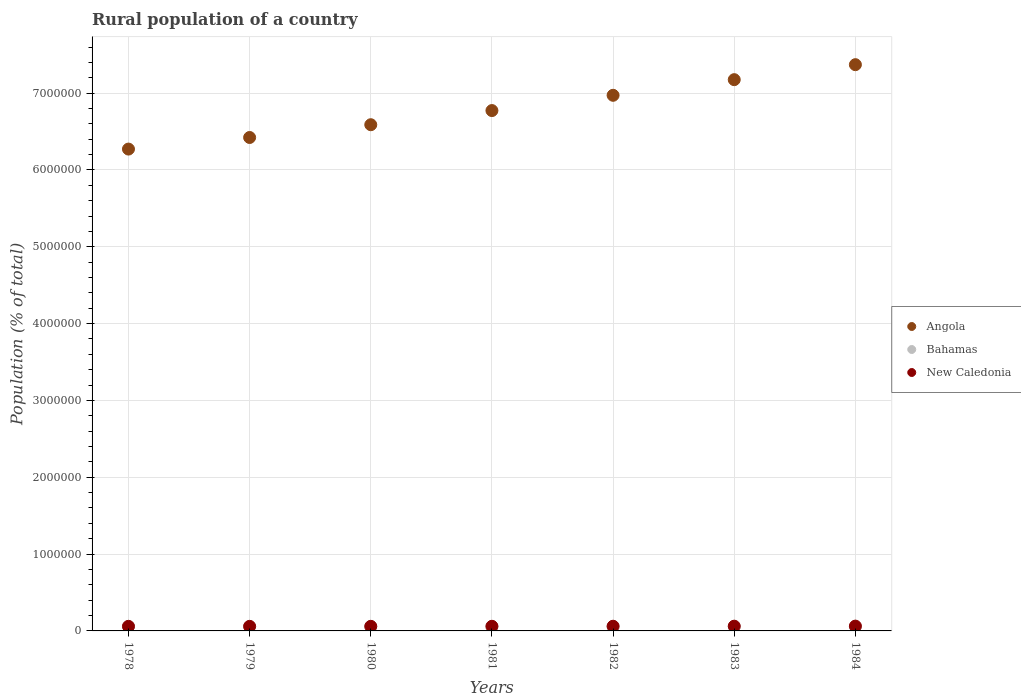How many different coloured dotlines are there?
Make the answer very short. 3. Is the number of dotlines equal to the number of legend labels?
Make the answer very short. Yes. What is the rural population in New Caledonia in 1982?
Provide a short and direct response. 6.09e+04. Across all years, what is the maximum rural population in Bahamas?
Ensure brevity in your answer.  5.67e+04. Across all years, what is the minimum rural population in New Caledonia?
Offer a very short reply. 5.95e+04. In which year was the rural population in Bahamas maximum?
Give a very brief answer. 1979. In which year was the rural population in New Caledonia minimum?
Make the answer very short. 1979. What is the total rural population in Angola in the graph?
Ensure brevity in your answer.  4.76e+07. What is the difference between the rural population in Angola in 1978 and that in 1984?
Offer a very short reply. -1.10e+06. What is the difference between the rural population in New Caledonia in 1983 and the rural population in Bahamas in 1980?
Provide a short and direct response. 5000. What is the average rural population in Bahamas per year?
Ensure brevity in your answer.  5.62e+04. In the year 1984, what is the difference between the rural population in Angola and rural population in Bahamas?
Offer a very short reply. 7.32e+06. What is the ratio of the rural population in Angola in 1979 to that in 1984?
Provide a short and direct response. 0.87. Is the difference between the rural population in Angola in 1981 and 1983 greater than the difference between the rural population in Bahamas in 1981 and 1983?
Offer a terse response. No. What is the difference between the highest and the second highest rural population in Bahamas?
Keep it short and to the point. 26. What is the difference between the highest and the lowest rural population in New Caledonia?
Give a very brief answer. 3156. In how many years, is the rural population in Angola greater than the average rural population in Angola taken over all years?
Make the answer very short. 3. Is the sum of the rural population in Angola in 1980 and 1983 greater than the maximum rural population in New Caledonia across all years?
Give a very brief answer. Yes. Does the rural population in New Caledonia monotonically increase over the years?
Offer a terse response. No. How many dotlines are there?
Give a very brief answer. 3. What is the difference between two consecutive major ticks on the Y-axis?
Offer a very short reply. 1.00e+06. Are the values on the major ticks of Y-axis written in scientific E-notation?
Offer a terse response. No. Does the graph contain any zero values?
Give a very brief answer. No. What is the title of the graph?
Make the answer very short. Rural population of a country. What is the label or title of the X-axis?
Keep it short and to the point. Years. What is the label or title of the Y-axis?
Offer a terse response. Population (% of total). What is the Population (% of total) of Angola in 1978?
Make the answer very short. 6.27e+06. What is the Population (% of total) in Bahamas in 1978?
Provide a succinct answer. 5.67e+04. What is the Population (% of total) in New Caledonia in 1978?
Provide a short and direct response. 5.96e+04. What is the Population (% of total) of Angola in 1979?
Your answer should be very brief. 6.42e+06. What is the Population (% of total) of Bahamas in 1979?
Give a very brief answer. 5.67e+04. What is the Population (% of total) in New Caledonia in 1979?
Your answer should be compact. 5.95e+04. What is the Population (% of total) in Angola in 1980?
Keep it short and to the point. 6.59e+06. What is the Population (% of total) in Bahamas in 1980?
Ensure brevity in your answer.  5.67e+04. What is the Population (% of total) of New Caledonia in 1980?
Make the answer very short. 5.96e+04. What is the Population (% of total) in Angola in 1981?
Your answer should be compact. 6.77e+06. What is the Population (% of total) in Bahamas in 1981?
Give a very brief answer. 5.63e+04. What is the Population (% of total) of New Caledonia in 1981?
Offer a terse response. 6.02e+04. What is the Population (% of total) in Angola in 1982?
Give a very brief answer. 6.97e+06. What is the Population (% of total) of Bahamas in 1982?
Provide a short and direct response. 5.60e+04. What is the Population (% of total) in New Caledonia in 1982?
Offer a terse response. 6.09e+04. What is the Population (% of total) in Angola in 1983?
Ensure brevity in your answer.  7.18e+06. What is the Population (% of total) in Bahamas in 1983?
Your answer should be compact. 5.57e+04. What is the Population (% of total) of New Caledonia in 1983?
Provide a succinct answer. 6.17e+04. What is the Population (% of total) of Angola in 1984?
Your response must be concise. 7.37e+06. What is the Population (% of total) in Bahamas in 1984?
Offer a terse response. 5.52e+04. What is the Population (% of total) of New Caledonia in 1984?
Ensure brevity in your answer.  6.27e+04. Across all years, what is the maximum Population (% of total) of Angola?
Offer a very short reply. 7.37e+06. Across all years, what is the maximum Population (% of total) in Bahamas?
Keep it short and to the point. 5.67e+04. Across all years, what is the maximum Population (% of total) of New Caledonia?
Offer a terse response. 6.27e+04. Across all years, what is the minimum Population (% of total) of Angola?
Offer a terse response. 6.27e+06. Across all years, what is the minimum Population (% of total) in Bahamas?
Offer a terse response. 5.52e+04. Across all years, what is the minimum Population (% of total) in New Caledonia?
Provide a short and direct response. 5.95e+04. What is the total Population (% of total) of Angola in the graph?
Ensure brevity in your answer.  4.76e+07. What is the total Population (% of total) of Bahamas in the graph?
Offer a terse response. 3.93e+05. What is the total Population (% of total) in New Caledonia in the graph?
Offer a very short reply. 4.24e+05. What is the difference between the Population (% of total) of Angola in 1978 and that in 1979?
Make the answer very short. -1.51e+05. What is the difference between the Population (% of total) of Bahamas in 1978 and that in 1979?
Keep it short and to the point. -26. What is the difference between the Population (% of total) of New Caledonia in 1978 and that in 1979?
Your answer should be very brief. 104. What is the difference between the Population (% of total) in Angola in 1978 and that in 1980?
Provide a succinct answer. -3.17e+05. What is the difference between the Population (% of total) of Angola in 1978 and that in 1981?
Your response must be concise. -5.01e+05. What is the difference between the Population (% of total) of Bahamas in 1978 and that in 1981?
Make the answer very short. 324. What is the difference between the Population (% of total) in New Caledonia in 1978 and that in 1981?
Ensure brevity in your answer.  -576. What is the difference between the Population (% of total) of Angola in 1978 and that in 1982?
Make the answer very short. -7.00e+05. What is the difference between the Population (% of total) of Bahamas in 1978 and that in 1982?
Provide a short and direct response. 653. What is the difference between the Population (% of total) in New Caledonia in 1978 and that in 1982?
Your answer should be compact. -1302. What is the difference between the Population (% of total) in Angola in 1978 and that in 1983?
Offer a terse response. -9.04e+05. What is the difference between the Population (% of total) of Bahamas in 1978 and that in 1983?
Ensure brevity in your answer.  1013. What is the difference between the Population (% of total) of New Caledonia in 1978 and that in 1983?
Provide a short and direct response. -2058. What is the difference between the Population (% of total) in Angola in 1978 and that in 1984?
Provide a short and direct response. -1.10e+06. What is the difference between the Population (% of total) of Bahamas in 1978 and that in 1984?
Your response must be concise. 1433. What is the difference between the Population (% of total) of New Caledonia in 1978 and that in 1984?
Your response must be concise. -3052. What is the difference between the Population (% of total) in Angola in 1979 and that in 1980?
Give a very brief answer. -1.66e+05. What is the difference between the Population (% of total) of New Caledonia in 1979 and that in 1980?
Make the answer very short. -124. What is the difference between the Population (% of total) of Angola in 1979 and that in 1981?
Provide a short and direct response. -3.50e+05. What is the difference between the Population (% of total) in Bahamas in 1979 and that in 1981?
Offer a very short reply. 350. What is the difference between the Population (% of total) of New Caledonia in 1979 and that in 1981?
Offer a terse response. -680. What is the difference between the Population (% of total) in Angola in 1979 and that in 1982?
Ensure brevity in your answer.  -5.49e+05. What is the difference between the Population (% of total) in Bahamas in 1979 and that in 1982?
Offer a very short reply. 679. What is the difference between the Population (% of total) in New Caledonia in 1979 and that in 1982?
Give a very brief answer. -1406. What is the difference between the Population (% of total) in Angola in 1979 and that in 1983?
Your answer should be compact. -7.53e+05. What is the difference between the Population (% of total) in Bahamas in 1979 and that in 1983?
Make the answer very short. 1039. What is the difference between the Population (% of total) of New Caledonia in 1979 and that in 1983?
Give a very brief answer. -2162. What is the difference between the Population (% of total) in Angola in 1979 and that in 1984?
Keep it short and to the point. -9.48e+05. What is the difference between the Population (% of total) of Bahamas in 1979 and that in 1984?
Your answer should be compact. 1459. What is the difference between the Population (% of total) in New Caledonia in 1979 and that in 1984?
Give a very brief answer. -3156. What is the difference between the Population (% of total) in Angola in 1980 and that in 1981?
Provide a short and direct response. -1.84e+05. What is the difference between the Population (% of total) in Bahamas in 1980 and that in 1981?
Give a very brief answer. 320. What is the difference between the Population (% of total) of New Caledonia in 1980 and that in 1981?
Ensure brevity in your answer.  -556. What is the difference between the Population (% of total) of Angola in 1980 and that in 1982?
Your answer should be compact. -3.83e+05. What is the difference between the Population (% of total) in Bahamas in 1980 and that in 1982?
Ensure brevity in your answer.  649. What is the difference between the Population (% of total) of New Caledonia in 1980 and that in 1982?
Your response must be concise. -1282. What is the difference between the Population (% of total) of Angola in 1980 and that in 1983?
Provide a succinct answer. -5.87e+05. What is the difference between the Population (% of total) in Bahamas in 1980 and that in 1983?
Make the answer very short. 1009. What is the difference between the Population (% of total) in New Caledonia in 1980 and that in 1983?
Offer a terse response. -2038. What is the difference between the Population (% of total) in Angola in 1980 and that in 1984?
Offer a terse response. -7.82e+05. What is the difference between the Population (% of total) of Bahamas in 1980 and that in 1984?
Your response must be concise. 1429. What is the difference between the Population (% of total) in New Caledonia in 1980 and that in 1984?
Offer a terse response. -3032. What is the difference between the Population (% of total) of Angola in 1981 and that in 1982?
Offer a terse response. -1.99e+05. What is the difference between the Population (% of total) of Bahamas in 1981 and that in 1982?
Your answer should be very brief. 329. What is the difference between the Population (% of total) in New Caledonia in 1981 and that in 1982?
Provide a short and direct response. -726. What is the difference between the Population (% of total) of Angola in 1981 and that in 1983?
Provide a short and direct response. -4.02e+05. What is the difference between the Population (% of total) in Bahamas in 1981 and that in 1983?
Provide a short and direct response. 689. What is the difference between the Population (% of total) of New Caledonia in 1981 and that in 1983?
Make the answer very short. -1482. What is the difference between the Population (% of total) in Angola in 1981 and that in 1984?
Your response must be concise. -5.97e+05. What is the difference between the Population (% of total) of Bahamas in 1981 and that in 1984?
Provide a succinct answer. 1109. What is the difference between the Population (% of total) in New Caledonia in 1981 and that in 1984?
Your answer should be very brief. -2476. What is the difference between the Population (% of total) of Angola in 1982 and that in 1983?
Provide a short and direct response. -2.04e+05. What is the difference between the Population (% of total) in Bahamas in 1982 and that in 1983?
Your answer should be very brief. 360. What is the difference between the Population (% of total) in New Caledonia in 1982 and that in 1983?
Offer a terse response. -756. What is the difference between the Population (% of total) of Angola in 1982 and that in 1984?
Your answer should be very brief. -3.99e+05. What is the difference between the Population (% of total) of Bahamas in 1982 and that in 1984?
Give a very brief answer. 780. What is the difference between the Population (% of total) of New Caledonia in 1982 and that in 1984?
Give a very brief answer. -1750. What is the difference between the Population (% of total) in Angola in 1983 and that in 1984?
Your answer should be very brief. -1.95e+05. What is the difference between the Population (% of total) of Bahamas in 1983 and that in 1984?
Provide a succinct answer. 420. What is the difference between the Population (% of total) in New Caledonia in 1983 and that in 1984?
Ensure brevity in your answer.  -994. What is the difference between the Population (% of total) in Angola in 1978 and the Population (% of total) in Bahamas in 1979?
Offer a terse response. 6.22e+06. What is the difference between the Population (% of total) in Angola in 1978 and the Population (% of total) in New Caledonia in 1979?
Offer a very short reply. 6.21e+06. What is the difference between the Population (% of total) in Bahamas in 1978 and the Population (% of total) in New Caledonia in 1979?
Your response must be concise. -2834. What is the difference between the Population (% of total) of Angola in 1978 and the Population (% of total) of Bahamas in 1980?
Ensure brevity in your answer.  6.22e+06. What is the difference between the Population (% of total) in Angola in 1978 and the Population (% of total) in New Caledonia in 1980?
Your answer should be compact. 6.21e+06. What is the difference between the Population (% of total) of Bahamas in 1978 and the Population (% of total) of New Caledonia in 1980?
Give a very brief answer. -2958. What is the difference between the Population (% of total) of Angola in 1978 and the Population (% of total) of Bahamas in 1981?
Keep it short and to the point. 6.22e+06. What is the difference between the Population (% of total) of Angola in 1978 and the Population (% of total) of New Caledonia in 1981?
Give a very brief answer. 6.21e+06. What is the difference between the Population (% of total) of Bahamas in 1978 and the Population (% of total) of New Caledonia in 1981?
Your answer should be very brief. -3514. What is the difference between the Population (% of total) of Angola in 1978 and the Population (% of total) of Bahamas in 1982?
Your response must be concise. 6.22e+06. What is the difference between the Population (% of total) of Angola in 1978 and the Population (% of total) of New Caledonia in 1982?
Your answer should be compact. 6.21e+06. What is the difference between the Population (% of total) in Bahamas in 1978 and the Population (% of total) in New Caledonia in 1982?
Ensure brevity in your answer.  -4240. What is the difference between the Population (% of total) of Angola in 1978 and the Population (% of total) of Bahamas in 1983?
Your answer should be compact. 6.22e+06. What is the difference between the Population (% of total) in Angola in 1978 and the Population (% of total) in New Caledonia in 1983?
Keep it short and to the point. 6.21e+06. What is the difference between the Population (% of total) of Bahamas in 1978 and the Population (% of total) of New Caledonia in 1983?
Ensure brevity in your answer.  -4996. What is the difference between the Population (% of total) in Angola in 1978 and the Population (% of total) in Bahamas in 1984?
Provide a succinct answer. 6.22e+06. What is the difference between the Population (% of total) in Angola in 1978 and the Population (% of total) in New Caledonia in 1984?
Your answer should be very brief. 6.21e+06. What is the difference between the Population (% of total) of Bahamas in 1978 and the Population (% of total) of New Caledonia in 1984?
Your response must be concise. -5990. What is the difference between the Population (% of total) of Angola in 1979 and the Population (% of total) of Bahamas in 1980?
Ensure brevity in your answer.  6.37e+06. What is the difference between the Population (% of total) in Angola in 1979 and the Population (% of total) in New Caledonia in 1980?
Provide a succinct answer. 6.36e+06. What is the difference between the Population (% of total) of Bahamas in 1979 and the Population (% of total) of New Caledonia in 1980?
Give a very brief answer. -2932. What is the difference between the Population (% of total) of Angola in 1979 and the Population (% of total) of Bahamas in 1981?
Offer a very short reply. 6.37e+06. What is the difference between the Population (% of total) in Angola in 1979 and the Population (% of total) in New Caledonia in 1981?
Provide a succinct answer. 6.36e+06. What is the difference between the Population (% of total) in Bahamas in 1979 and the Population (% of total) in New Caledonia in 1981?
Keep it short and to the point. -3488. What is the difference between the Population (% of total) of Angola in 1979 and the Population (% of total) of Bahamas in 1982?
Provide a succinct answer. 6.37e+06. What is the difference between the Population (% of total) of Angola in 1979 and the Population (% of total) of New Caledonia in 1982?
Your answer should be very brief. 6.36e+06. What is the difference between the Population (% of total) of Bahamas in 1979 and the Population (% of total) of New Caledonia in 1982?
Give a very brief answer. -4214. What is the difference between the Population (% of total) in Angola in 1979 and the Population (% of total) in Bahamas in 1983?
Give a very brief answer. 6.37e+06. What is the difference between the Population (% of total) in Angola in 1979 and the Population (% of total) in New Caledonia in 1983?
Your answer should be very brief. 6.36e+06. What is the difference between the Population (% of total) in Bahamas in 1979 and the Population (% of total) in New Caledonia in 1983?
Your answer should be very brief. -4970. What is the difference between the Population (% of total) in Angola in 1979 and the Population (% of total) in Bahamas in 1984?
Offer a very short reply. 6.37e+06. What is the difference between the Population (% of total) in Angola in 1979 and the Population (% of total) in New Caledonia in 1984?
Keep it short and to the point. 6.36e+06. What is the difference between the Population (% of total) of Bahamas in 1979 and the Population (% of total) of New Caledonia in 1984?
Offer a very short reply. -5964. What is the difference between the Population (% of total) of Angola in 1980 and the Population (% of total) of Bahamas in 1981?
Your answer should be compact. 6.53e+06. What is the difference between the Population (% of total) in Angola in 1980 and the Population (% of total) in New Caledonia in 1981?
Your answer should be compact. 6.53e+06. What is the difference between the Population (% of total) of Bahamas in 1980 and the Population (% of total) of New Caledonia in 1981?
Provide a short and direct response. -3518. What is the difference between the Population (% of total) in Angola in 1980 and the Population (% of total) in Bahamas in 1982?
Your answer should be compact. 6.53e+06. What is the difference between the Population (% of total) in Angola in 1980 and the Population (% of total) in New Caledonia in 1982?
Provide a short and direct response. 6.53e+06. What is the difference between the Population (% of total) of Bahamas in 1980 and the Population (% of total) of New Caledonia in 1982?
Your answer should be compact. -4244. What is the difference between the Population (% of total) of Angola in 1980 and the Population (% of total) of Bahamas in 1983?
Your answer should be compact. 6.53e+06. What is the difference between the Population (% of total) of Angola in 1980 and the Population (% of total) of New Caledonia in 1983?
Offer a terse response. 6.53e+06. What is the difference between the Population (% of total) in Bahamas in 1980 and the Population (% of total) in New Caledonia in 1983?
Keep it short and to the point. -5000. What is the difference between the Population (% of total) of Angola in 1980 and the Population (% of total) of Bahamas in 1984?
Give a very brief answer. 6.53e+06. What is the difference between the Population (% of total) in Angola in 1980 and the Population (% of total) in New Caledonia in 1984?
Ensure brevity in your answer.  6.53e+06. What is the difference between the Population (% of total) in Bahamas in 1980 and the Population (% of total) in New Caledonia in 1984?
Keep it short and to the point. -5994. What is the difference between the Population (% of total) of Angola in 1981 and the Population (% of total) of Bahamas in 1982?
Provide a short and direct response. 6.72e+06. What is the difference between the Population (% of total) of Angola in 1981 and the Population (% of total) of New Caledonia in 1982?
Your answer should be very brief. 6.71e+06. What is the difference between the Population (% of total) of Bahamas in 1981 and the Population (% of total) of New Caledonia in 1982?
Your answer should be compact. -4564. What is the difference between the Population (% of total) of Angola in 1981 and the Population (% of total) of Bahamas in 1983?
Provide a short and direct response. 6.72e+06. What is the difference between the Population (% of total) in Angola in 1981 and the Population (% of total) in New Caledonia in 1983?
Provide a short and direct response. 6.71e+06. What is the difference between the Population (% of total) in Bahamas in 1981 and the Population (% of total) in New Caledonia in 1983?
Your answer should be very brief. -5320. What is the difference between the Population (% of total) of Angola in 1981 and the Population (% of total) of Bahamas in 1984?
Give a very brief answer. 6.72e+06. What is the difference between the Population (% of total) in Angola in 1981 and the Population (% of total) in New Caledonia in 1984?
Offer a very short reply. 6.71e+06. What is the difference between the Population (% of total) of Bahamas in 1981 and the Population (% of total) of New Caledonia in 1984?
Make the answer very short. -6314. What is the difference between the Population (% of total) in Angola in 1982 and the Population (% of total) in Bahamas in 1983?
Make the answer very short. 6.92e+06. What is the difference between the Population (% of total) in Angola in 1982 and the Population (% of total) in New Caledonia in 1983?
Ensure brevity in your answer.  6.91e+06. What is the difference between the Population (% of total) in Bahamas in 1982 and the Population (% of total) in New Caledonia in 1983?
Offer a very short reply. -5649. What is the difference between the Population (% of total) of Angola in 1982 and the Population (% of total) of Bahamas in 1984?
Ensure brevity in your answer.  6.92e+06. What is the difference between the Population (% of total) of Angola in 1982 and the Population (% of total) of New Caledonia in 1984?
Your answer should be compact. 6.91e+06. What is the difference between the Population (% of total) of Bahamas in 1982 and the Population (% of total) of New Caledonia in 1984?
Make the answer very short. -6643. What is the difference between the Population (% of total) of Angola in 1983 and the Population (% of total) of Bahamas in 1984?
Provide a succinct answer. 7.12e+06. What is the difference between the Population (% of total) of Angola in 1983 and the Population (% of total) of New Caledonia in 1984?
Offer a terse response. 7.11e+06. What is the difference between the Population (% of total) of Bahamas in 1983 and the Population (% of total) of New Caledonia in 1984?
Provide a short and direct response. -7003. What is the average Population (% of total) of Angola per year?
Offer a very short reply. 6.80e+06. What is the average Population (% of total) in Bahamas per year?
Provide a short and direct response. 5.62e+04. What is the average Population (% of total) of New Caledonia per year?
Your answer should be compact. 6.06e+04. In the year 1978, what is the difference between the Population (% of total) of Angola and Population (% of total) of Bahamas?
Offer a very short reply. 6.22e+06. In the year 1978, what is the difference between the Population (% of total) of Angola and Population (% of total) of New Caledonia?
Ensure brevity in your answer.  6.21e+06. In the year 1978, what is the difference between the Population (% of total) of Bahamas and Population (% of total) of New Caledonia?
Your response must be concise. -2938. In the year 1979, what is the difference between the Population (% of total) of Angola and Population (% of total) of Bahamas?
Your answer should be very brief. 6.37e+06. In the year 1979, what is the difference between the Population (% of total) in Angola and Population (% of total) in New Caledonia?
Your answer should be compact. 6.36e+06. In the year 1979, what is the difference between the Population (% of total) in Bahamas and Population (% of total) in New Caledonia?
Keep it short and to the point. -2808. In the year 1980, what is the difference between the Population (% of total) of Angola and Population (% of total) of Bahamas?
Provide a short and direct response. 6.53e+06. In the year 1980, what is the difference between the Population (% of total) in Angola and Population (% of total) in New Caledonia?
Offer a very short reply. 6.53e+06. In the year 1980, what is the difference between the Population (% of total) in Bahamas and Population (% of total) in New Caledonia?
Provide a short and direct response. -2962. In the year 1981, what is the difference between the Population (% of total) of Angola and Population (% of total) of Bahamas?
Keep it short and to the point. 6.72e+06. In the year 1981, what is the difference between the Population (% of total) in Angola and Population (% of total) in New Caledonia?
Ensure brevity in your answer.  6.71e+06. In the year 1981, what is the difference between the Population (% of total) of Bahamas and Population (% of total) of New Caledonia?
Your response must be concise. -3838. In the year 1982, what is the difference between the Population (% of total) of Angola and Population (% of total) of Bahamas?
Give a very brief answer. 6.92e+06. In the year 1982, what is the difference between the Population (% of total) in Angola and Population (% of total) in New Caledonia?
Provide a succinct answer. 6.91e+06. In the year 1982, what is the difference between the Population (% of total) in Bahamas and Population (% of total) in New Caledonia?
Your answer should be compact. -4893. In the year 1983, what is the difference between the Population (% of total) in Angola and Population (% of total) in Bahamas?
Ensure brevity in your answer.  7.12e+06. In the year 1983, what is the difference between the Population (% of total) in Angola and Population (% of total) in New Caledonia?
Provide a succinct answer. 7.11e+06. In the year 1983, what is the difference between the Population (% of total) in Bahamas and Population (% of total) in New Caledonia?
Your response must be concise. -6009. In the year 1984, what is the difference between the Population (% of total) of Angola and Population (% of total) of Bahamas?
Ensure brevity in your answer.  7.32e+06. In the year 1984, what is the difference between the Population (% of total) in Angola and Population (% of total) in New Caledonia?
Provide a succinct answer. 7.31e+06. In the year 1984, what is the difference between the Population (% of total) in Bahamas and Population (% of total) in New Caledonia?
Give a very brief answer. -7423. What is the ratio of the Population (% of total) in Angola in 1978 to that in 1979?
Offer a terse response. 0.98. What is the ratio of the Population (% of total) of Bahamas in 1978 to that in 1979?
Ensure brevity in your answer.  1. What is the ratio of the Population (% of total) in New Caledonia in 1978 to that in 1979?
Offer a very short reply. 1. What is the ratio of the Population (% of total) of Angola in 1978 to that in 1980?
Your answer should be compact. 0.95. What is the ratio of the Population (% of total) of Bahamas in 1978 to that in 1980?
Offer a very short reply. 1. What is the ratio of the Population (% of total) of New Caledonia in 1978 to that in 1980?
Your answer should be very brief. 1. What is the ratio of the Population (% of total) of Angola in 1978 to that in 1981?
Provide a succinct answer. 0.93. What is the ratio of the Population (% of total) of Bahamas in 1978 to that in 1981?
Provide a succinct answer. 1.01. What is the ratio of the Population (% of total) in New Caledonia in 1978 to that in 1981?
Offer a terse response. 0.99. What is the ratio of the Population (% of total) of Angola in 1978 to that in 1982?
Keep it short and to the point. 0.9. What is the ratio of the Population (% of total) of Bahamas in 1978 to that in 1982?
Offer a terse response. 1.01. What is the ratio of the Population (% of total) in New Caledonia in 1978 to that in 1982?
Your answer should be very brief. 0.98. What is the ratio of the Population (% of total) of Angola in 1978 to that in 1983?
Your answer should be compact. 0.87. What is the ratio of the Population (% of total) of Bahamas in 1978 to that in 1983?
Make the answer very short. 1.02. What is the ratio of the Population (% of total) in New Caledonia in 1978 to that in 1983?
Provide a short and direct response. 0.97. What is the ratio of the Population (% of total) in Angola in 1978 to that in 1984?
Provide a short and direct response. 0.85. What is the ratio of the Population (% of total) of Bahamas in 1978 to that in 1984?
Offer a terse response. 1.03. What is the ratio of the Population (% of total) in New Caledonia in 1978 to that in 1984?
Your response must be concise. 0.95. What is the ratio of the Population (% of total) of Angola in 1979 to that in 1980?
Provide a succinct answer. 0.97. What is the ratio of the Population (% of total) of Bahamas in 1979 to that in 1980?
Your answer should be compact. 1. What is the ratio of the Population (% of total) of New Caledonia in 1979 to that in 1980?
Give a very brief answer. 1. What is the ratio of the Population (% of total) in Angola in 1979 to that in 1981?
Give a very brief answer. 0.95. What is the ratio of the Population (% of total) in Bahamas in 1979 to that in 1981?
Your answer should be compact. 1.01. What is the ratio of the Population (% of total) in New Caledonia in 1979 to that in 1981?
Give a very brief answer. 0.99. What is the ratio of the Population (% of total) of Angola in 1979 to that in 1982?
Offer a terse response. 0.92. What is the ratio of the Population (% of total) in Bahamas in 1979 to that in 1982?
Keep it short and to the point. 1.01. What is the ratio of the Population (% of total) in New Caledonia in 1979 to that in 1982?
Make the answer very short. 0.98. What is the ratio of the Population (% of total) in Angola in 1979 to that in 1983?
Make the answer very short. 0.9. What is the ratio of the Population (% of total) of Bahamas in 1979 to that in 1983?
Ensure brevity in your answer.  1.02. What is the ratio of the Population (% of total) of New Caledonia in 1979 to that in 1983?
Keep it short and to the point. 0.96. What is the ratio of the Population (% of total) of Angola in 1979 to that in 1984?
Provide a short and direct response. 0.87. What is the ratio of the Population (% of total) of Bahamas in 1979 to that in 1984?
Provide a short and direct response. 1.03. What is the ratio of the Population (% of total) in New Caledonia in 1979 to that in 1984?
Provide a succinct answer. 0.95. What is the ratio of the Population (% of total) in Angola in 1980 to that in 1981?
Give a very brief answer. 0.97. What is the ratio of the Population (% of total) of Bahamas in 1980 to that in 1981?
Ensure brevity in your answer.  1.01. What is the ratio of the Population (% of total) in New Caledonia in 1980 to that in 1981?
Offer a terse response. 0.99. What is the ratio of the Population (% of total) in Angola in 1980 to that in 1982?
Provide a succinct answer. 0.95. What is the ratio of the Population (% of total) of Bahamas in 1980 to that in 1982?
Ensure brevity in your answer.  1.01. What is the ratio of the Population (% of total) of Angola in 1980 to that in 1983?
Offer a very short reply. 0.92. What is the ratio of the Population (% of total) in Bahamas in 1980 to that in 1983?
Offer a very short reply. 1.02. What is the ratio of the Population (% of total) of New Caledonia in 1980 to that in 1983?
Your response must be concise. 0.97. What is the ratio of the Population (% of total) in Angola in 1980 to that in 1984?
Keep it short and to the point. 0.89. What is the ratio of the Population (% of total) in Bahamas in 1980 to that in 1984?
Provide a short and direct response. 1.03. What is the ratio of the Population (% of total) of New Caledonia in 1980 to that in 1984?
Provide a short and direct response. 0.95. What is the ratio of the Population (% of total) of Angola in 1981 to that in 1982?
Your response must be concise. 0.97. What is the ratio of the Population (% of total) in Bahamas in 1981 to that in 1982?
Your answer should be very brief. 1.01. What is the ratio of the Population (% of total) of Angola in 1981 to that in 1983?
Give a very brief answer. 0.94. What is the ratio of the Population (% of total) of Bahamas in 1981 to that in 1983?
Your answer should be very brief. 1.01. What is the ratio of the Population (% of total) in New Caledonia in 1981 to that in 1983?
Provide a succinct answer. 0.98. What is the ratio of the Population (% of total) of Angola in 1981 to that in 1984?
Offer a terse response. 0.92. What is the ratio of the Population (% of total) of Bahamas in 1981 to that in 1984?
Provide a short and direct response. 1.02. What is the ratio of the Population (% of total) of New Caledonia in 1981 to that in 1984?
Your response must be concise. 0.96. What is the ratio of the Population (% of total) of Angola in 1982 to that in 1983?
Give a very brief answer. 0.97. What is the ratio of the Population (% of total) of Angola in 1982 to that in 1984?
Offer a terse response. 0.95. What is the ratio of the Population (% of total) in Bahamas in 1982 to that in 1984?
Your answer should be very brief. 1.01. What is the ratio of the Population (% of total) of New Caledonia in 1982 to that in 1984?
Provide a short and direct response. 0.97. What is the ratio of the Population (% of total) of Angola in 1983 to that in 1984?
Provide a short and direct response. 0.97. What is the ratio of the Population (% of total) in Bahamas in 1983 to that in 1984?
Offer a very short reply. 1.01. What is the ratio of the Population (% of total) in New Caledonia in 1983 to that in 1984?
Make the answer very short. 0.98. What is the difference between the highest and the second highest Population (% of total) of Angola?
Make the answer very short. 1.95e+05. What is the difference between the highest and the second highest Population (% of total) of Bahamas?
Give a very brief answer. 26. What is the difference between the highest and the second highest Population (% of total) of New Caledonia?
Your answer should be compact. 994. What is the difference between the highest and the lowest Population (% of total) in Angola?
Your answer should be very brief. 1.10e+06. What is the difference between the highest and the lowest Population (% of total) of Bahamas?
Give a very brief answer. 1459. What is the difference between the highest and the lowest Population (% of total) in New Caledonia?
Offer a terse response. 3156. 